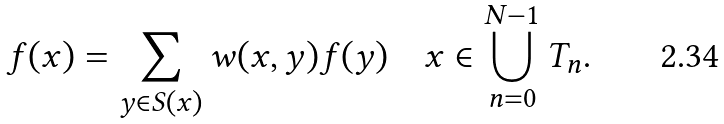<formula> <loc_0><loc_0><loc_500><loc_500>f ( x ) = \sum _ { y \in S ( x ) } w ( x , y ) f ( y ) \quad x \in \bigcup ^ { N - 1 } _ { n = 0 } T _ { n } .</formula> 